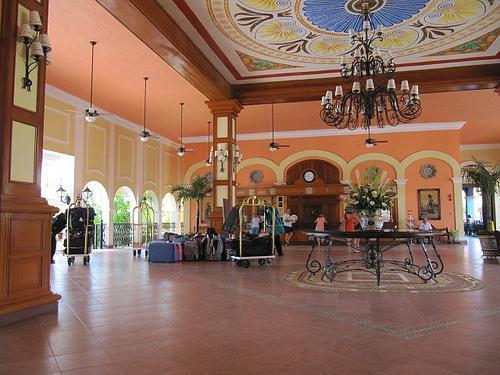How many gold carts are there?
Give a very brief answer. 3. How many ceiling fans are in the picture?
Give a very brief answer. 6. How many clocks are in the photo?
Give a very brief answer. 1. How many plants are inside the lobby?
Give a very brief answer. 3. 